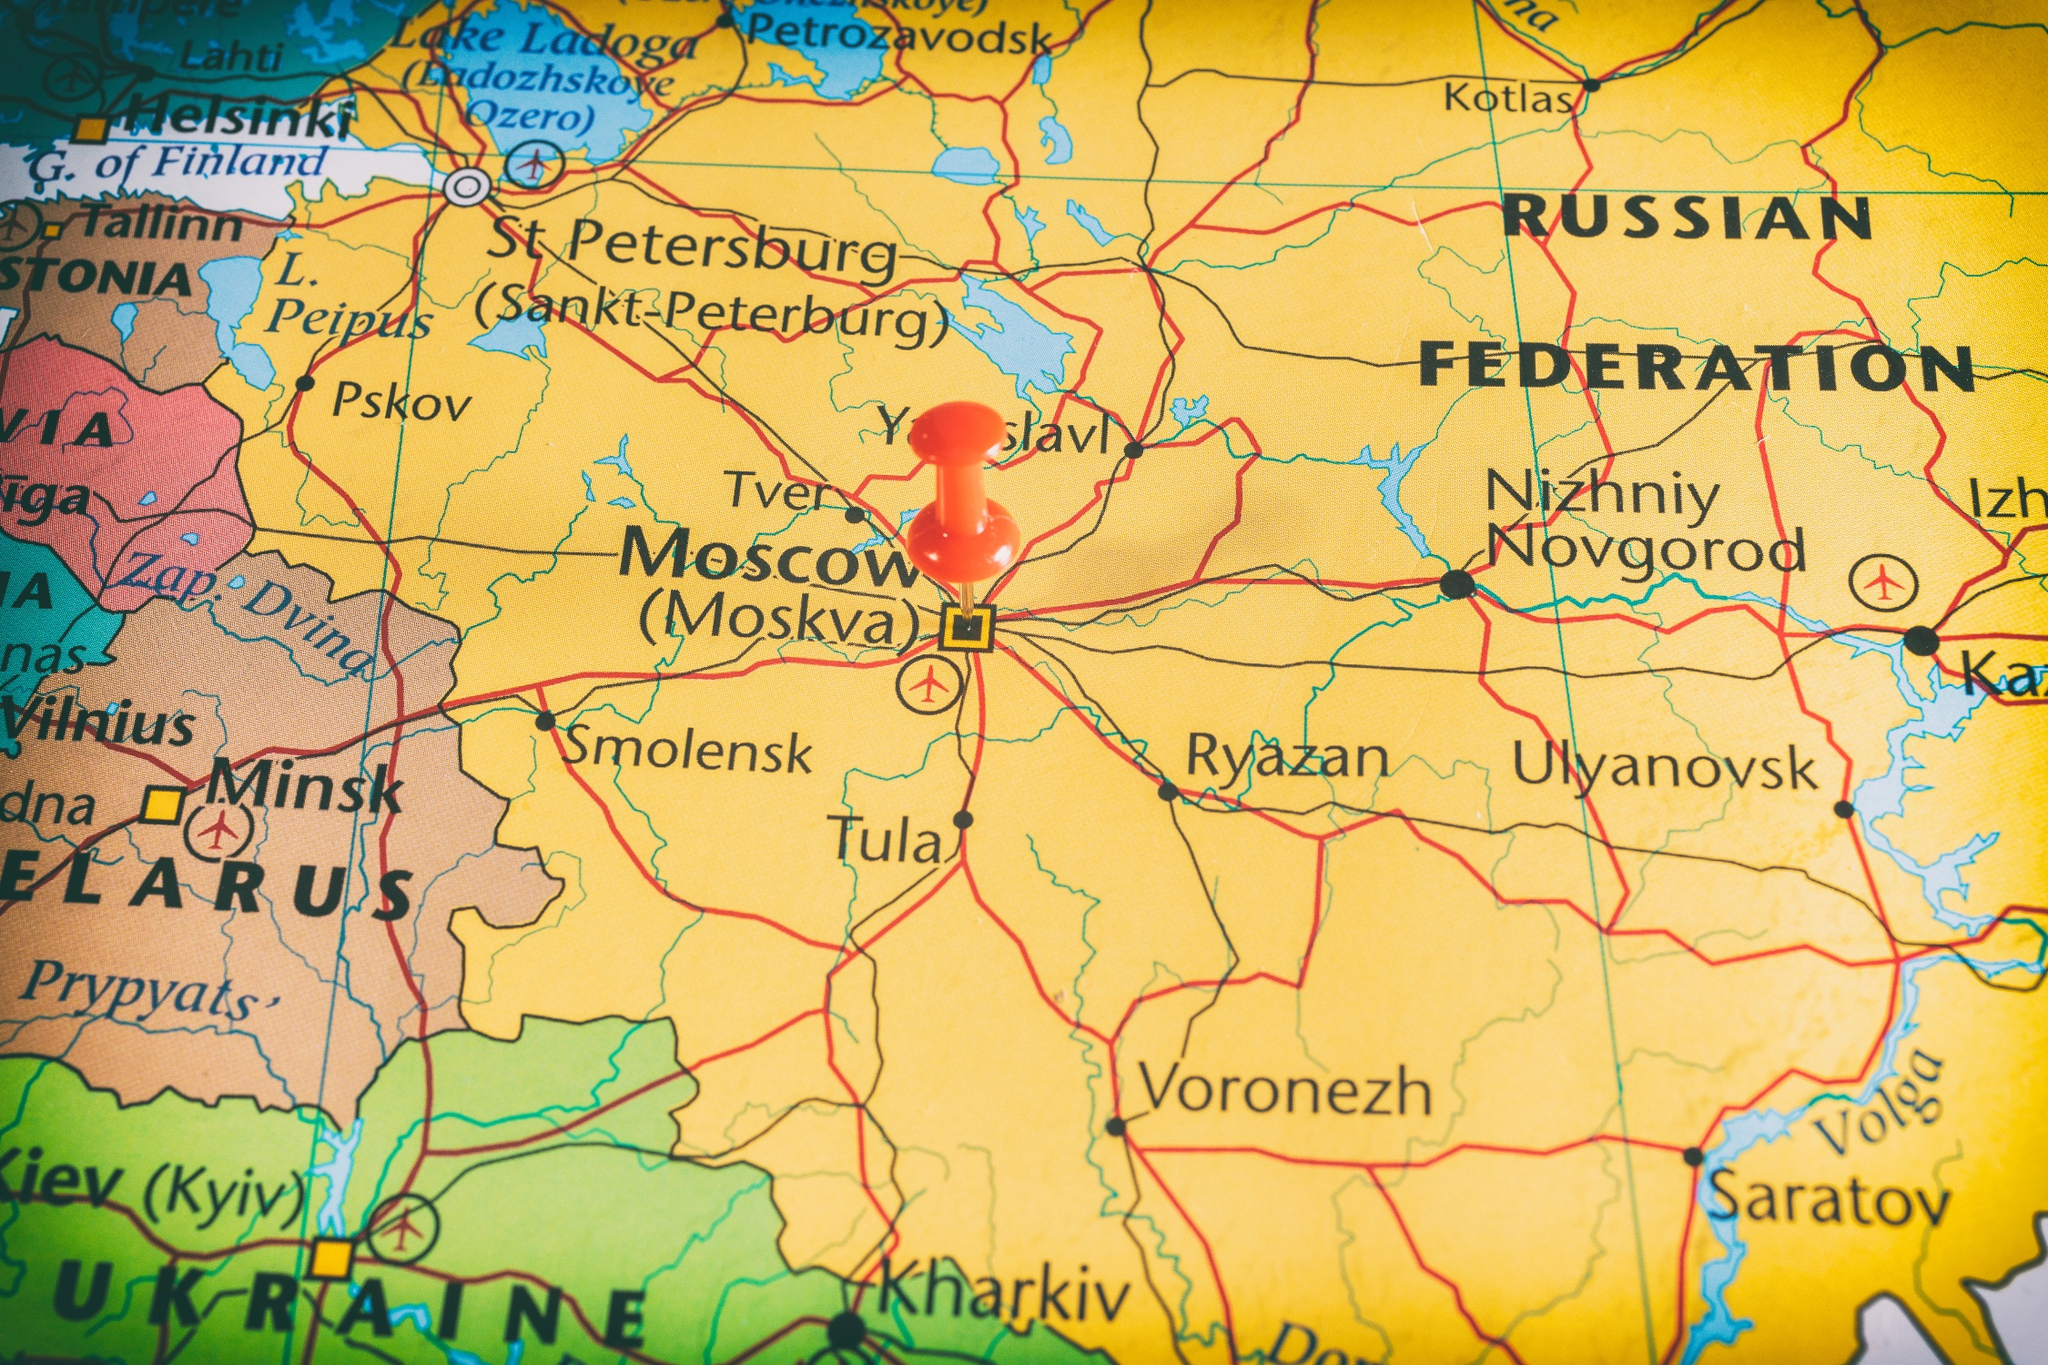If you could travel anywhere on this map instantly, where would you go and why? Given the opportunity to travel instantly to any place on this map, I would choose to visit St. Petersburg. Known for its rich history and stunning architecture, St. Petersburg was the imperial capital of Russia and is often referred to as the cultural capital of the country. It is renowned for its historic architecture, including the Winter Palace, the Hermitage Museum, and the Church of the Savior on Spilled Blood. The city's layout, reflected partially on the map, indicates its prominence and ties to Russia's imperial past. Visiting St. Petersburg would offer a fascinating blend of historical exploration and cultural richness, a true embodiment of Russia's grand history and artistic achievements. Imagine the map came to life. How would the cities and roads interact with each other? If the map came to life, it would transform into a dynamic and animated representation of Russia and its surrounding regions. Cities would be bustling with activity, roads filled with moving vehicles, and people commuting. Moscow would be a vibrant hub, radiating energy as the central node connecting various regions. Cars, trains, and airplanes would zoom across the roads and skies, emphasizing the network of transportation that keeps the country interconnected. Major cities like St. Petersburg, Nizhniy Novgorod, and Minsk would interact through constant communication and exchange, signifying economic trade and cultural exchange. The rivers and lakes would shimmer with life, with boats and ships cruising to transport goods. Each city would showcase its historical landmarks, cultural events, and local traditions, bringing a rich tapestry of Russia's diversity to life. The borders, typically static lines on a map, would be pulsating with the movement of people, reflecting the flowing interactions that define the region's dynamic nature.  What kind of adventure story could take place across these highlighted regions? In a land where ancient empires once rose and fell, a young cartographer from Moscow discovers an enigmatic map during a routine survey. This map, unlike any other, is said to hold the key to the lost treasures of Tsar Ivan IV, hidden across the vast expanse of Russia. The journey begins in Moscow, where the protagonist deciphers the first clue leading them to St. Petersburg. Here, amid the grand palaces and hidden catacombs, they uncover clues pointing to ancient manuscripts in the libraries of Tula, revealing forgotten paths. Each city from Smolensk to Ulyanovsk holds a piece of the puzzle, guarded by modern-day descendants of the Tsar’s most trusted advisors. As the map comes to life, roads and rivers animate to guide the protagonist through treacherous terrains, historical battlegrounds, and mystical encounters. The journey tests their wit, courage, and perseverance, leading to a climactic discovery beneath the historic streets of Nizhniy Novgorod. The adventure uncovers not just gold, but hidden truths about Russia's storied past, forging new paths in the annals of history. 